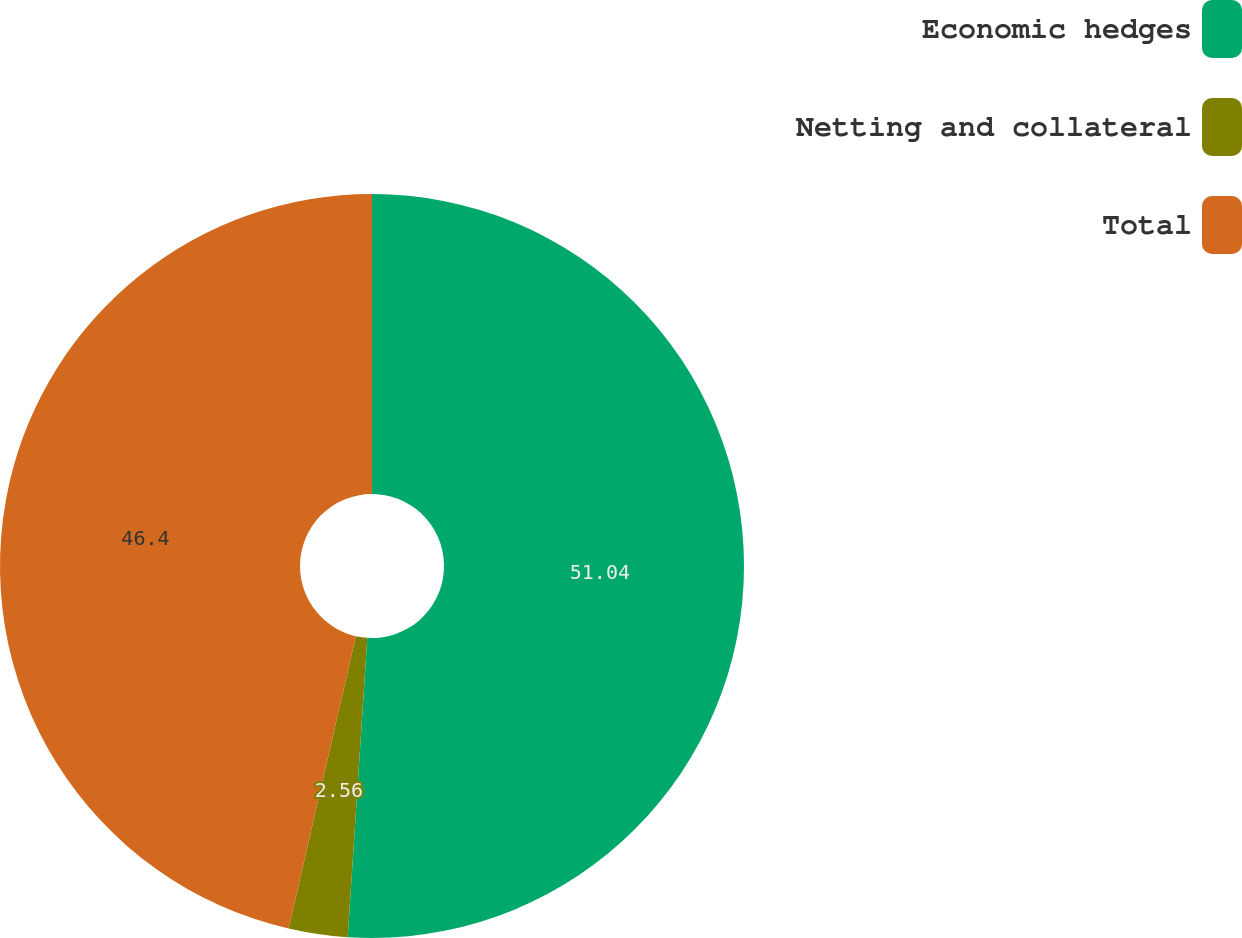<chart> <loc_0><loc_0><loc_500><loc_500><pie_chart><fcel>Economic hedges<fcel>Netting and collateral<fcel>Total<nl><fcel>51.04%<fcel>2.56%<fcel>46.4%<nl></chart> 